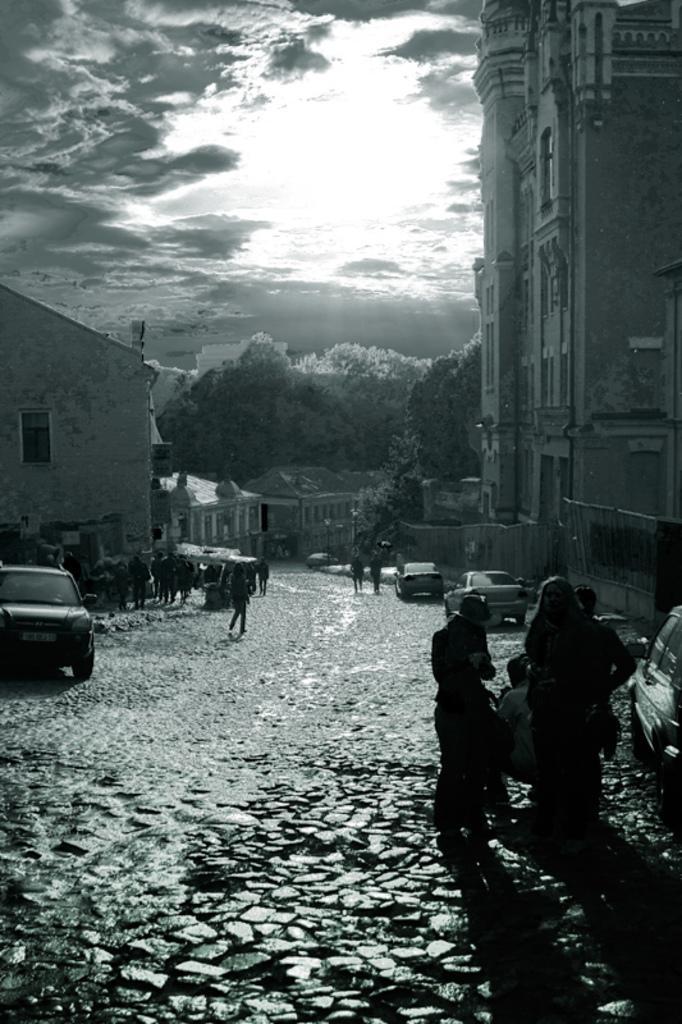How would you summarize this image in a sentence or two? In this image I can see the sky and buildings and persons visible on the road and vehicles visible on the road. And this picture is very dark 